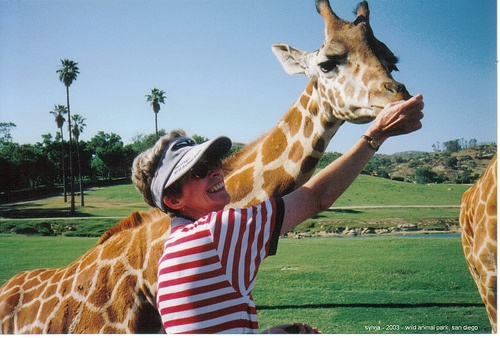Describe the objects in this image and their specific colors. I can see giraffe in darkgray, brown, tan, and lightgray tones, people in darkgray, maroon, black, lightgray, and gray tones, and giraffe in darkgray, tan, and olive tones in this image. 